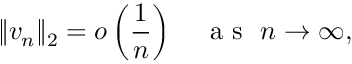<formula> <loc_0><loc_0><loc_500><loc_500>\| { v _ { n } } \| _ { 2 } = o \left ( \frac { 1 } { n } \right ) \quad a s \ n \rightarrow \infty ,</formula> 